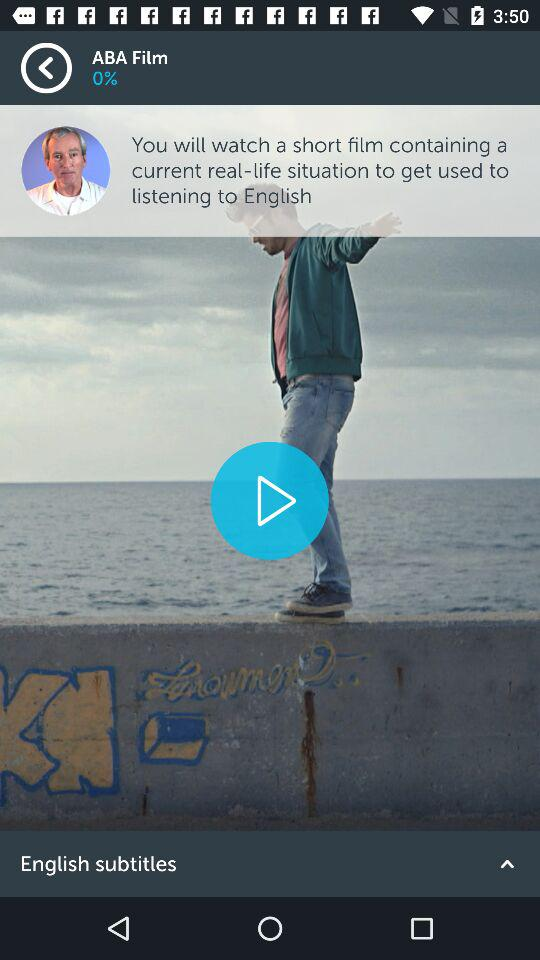What is the name of the production house? The name of the production house is "ABA Film". 